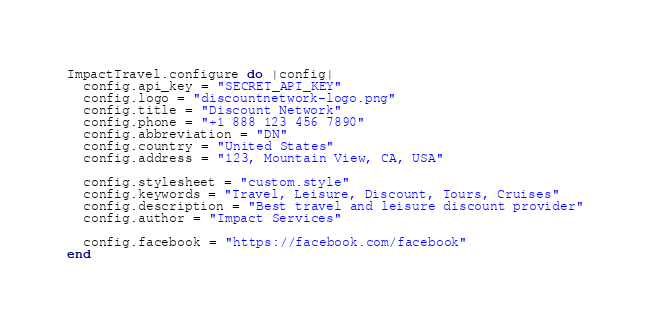Convert code to text. <code><loc_0><loc_0><loc_500><loc_500><_Ruby_>ImpactTravel.configure do |config|
  config.api_key = "SECRET_API_KEY"
  config.logo = "discountnetwork-logo.png"
  config.title = "Discount Network"
  config.phone = "+1 888 123 456 7890"
  config.abbreviation = "DN"
  config.country = "United States"
  config.address = "123, Mountain View, CA, USA"

  config.stylesheet = "custom.style"
  config.keywords = "Travel, Leisure, Discount, Tours, Cruises"
  config.description = "Best travel and leisure discount provider"
  config.author = "Impact Services"

  config.facebook = "https://facebook.com/facebook"
end
</code> 